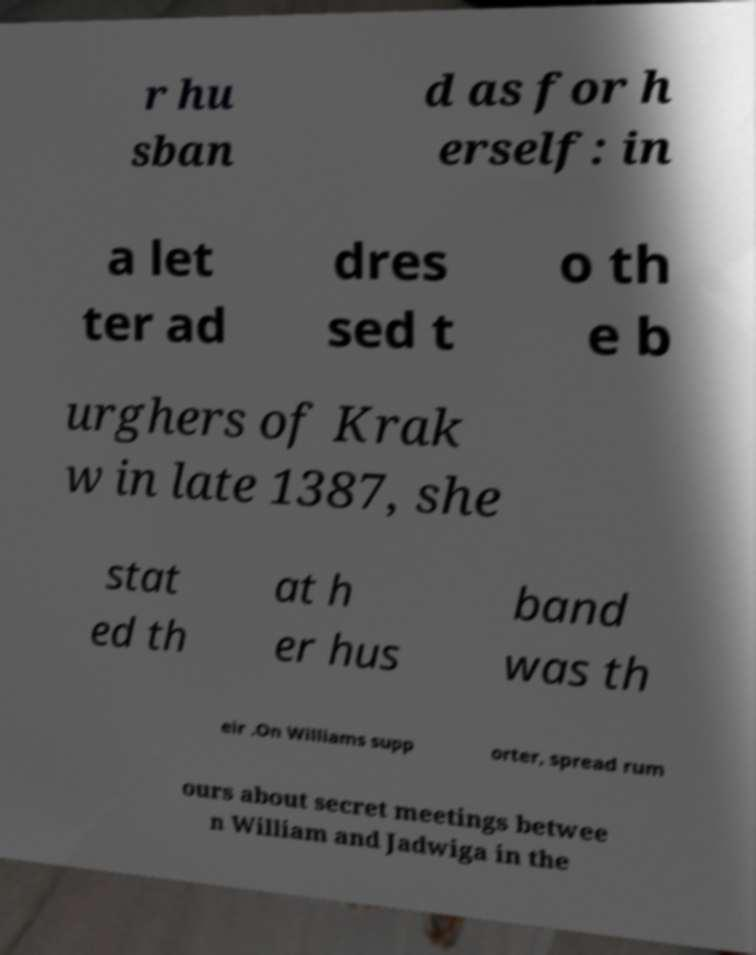For documentation purposes, I need the text within this image transcribed. Could you provide that? r hu sban d as for h erself: in a let ter ad dres sed t o th e b urghers of Krak w in late 1387, she stat ed th at h er hus band was th eir .On Williams supp orter, spread rum ours about secret meetings betwee n William and Jadwiga in the 